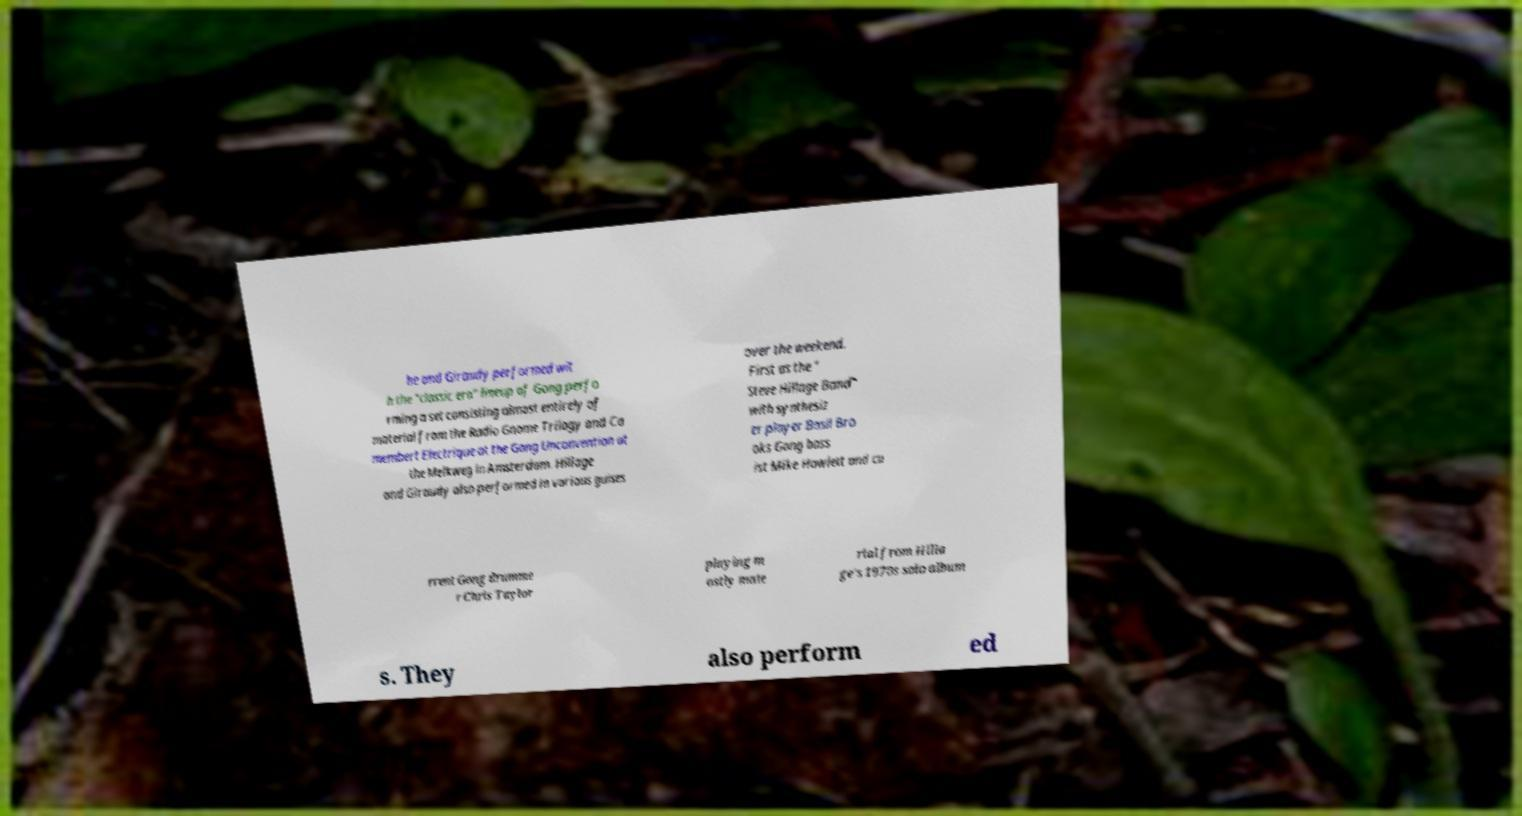What messages or text are displayed in this image? I need them in a readable, typed format. he and Giraudy performed wit h the "classic era" lineup of Gong perfo rming a set consisting almost entirely of material from the Radio Gnome Trilogy and Ca membert Electrique at the Gong Unconvention at the Melkweg in Amsterdam. Hillage and Giraudy also performed in various guises over the weekend. First as the " Steve Hillage Band" with synthesiz er player Basil Bro oks Gong bass ist Mike Howlett and cu rrent Gong drumme r Chris Taylor playing m ostly mate rial from Hilla ge's 1970s solo album s. They also perform ed 